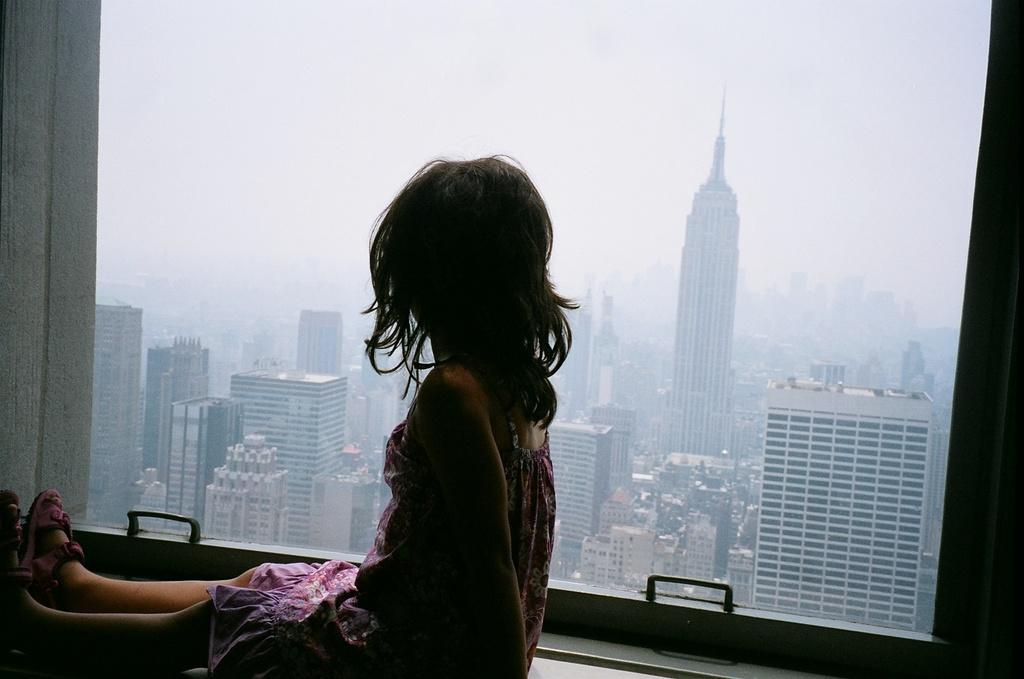Who is the main subject in the picture? There is a girl child in the picture. Where is the girl child located in the image? The girl child is sitting near a window. What can be seen through the window in the image? Buildings, tower buildings, and the sky are visible through the window. What type of hammer is the girl child using to peel a potato in the image? There is no hammer or potato present in the image; the girl child is sitting near a window with a view of buildings and the sky. 